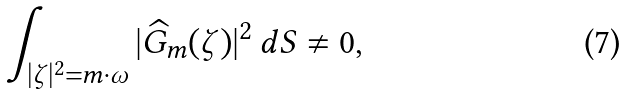Convert formula to latex. <formula><loc_0><loc_0><loc_500><loc_500>\int _ { | \zeta | ^ { 2 } = m \cdot \omega } | \widehat { G } _ { m } ( \zeta ) | ^ { 2 } \, d S \neq 0 ,</formula> 